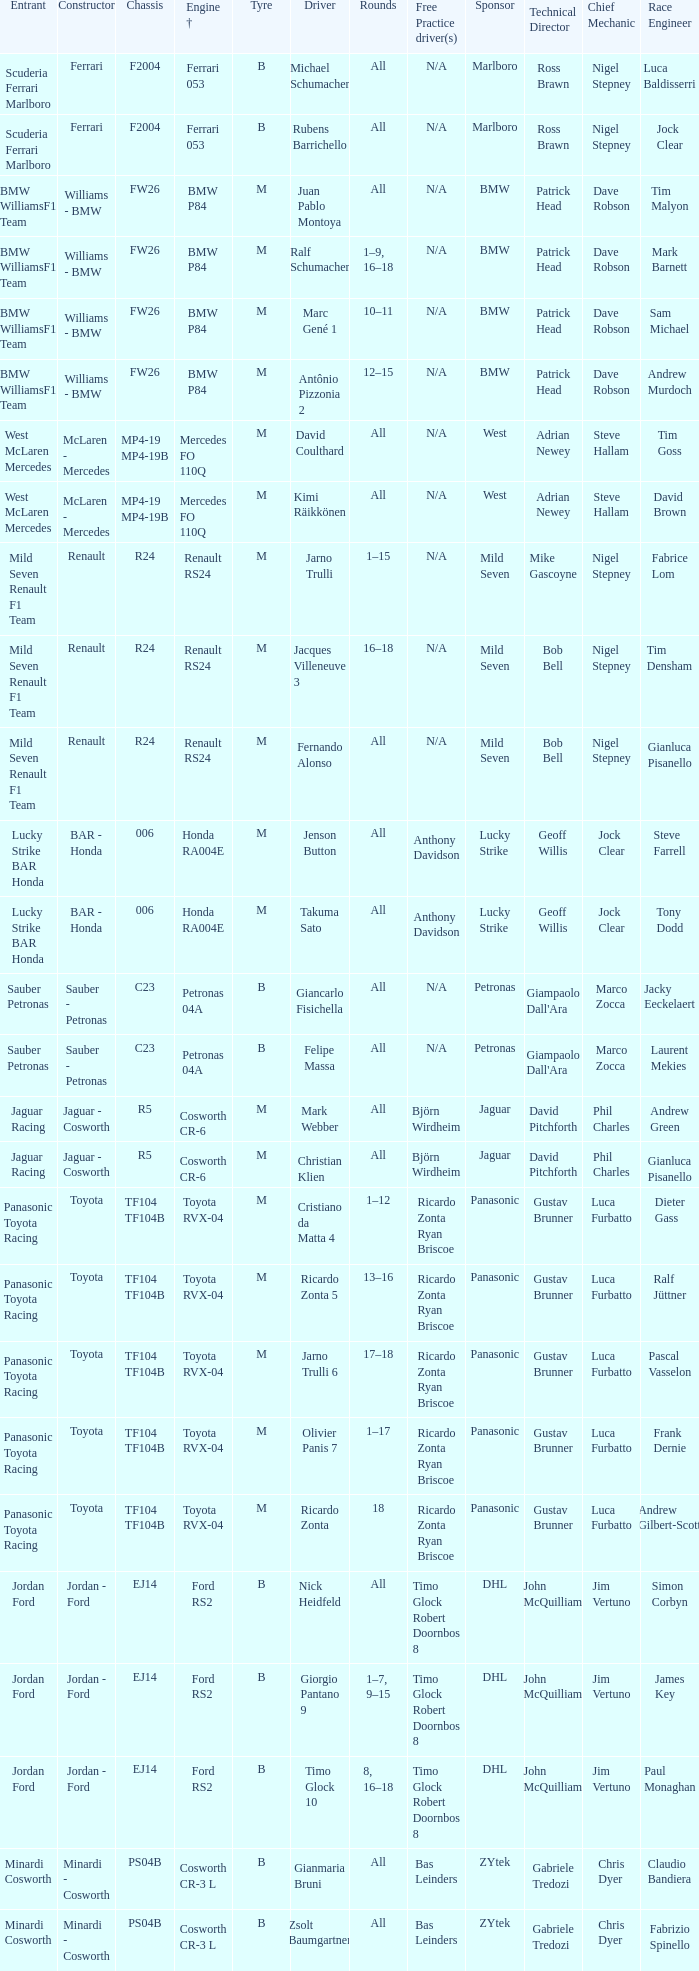What kind of free practice is there with a Ford RS2 engine +? Timo Glock Robert Doornbos 8, Timo Glock Robert Doornbos 8, Timo Glock Robert Doornbos 8. 